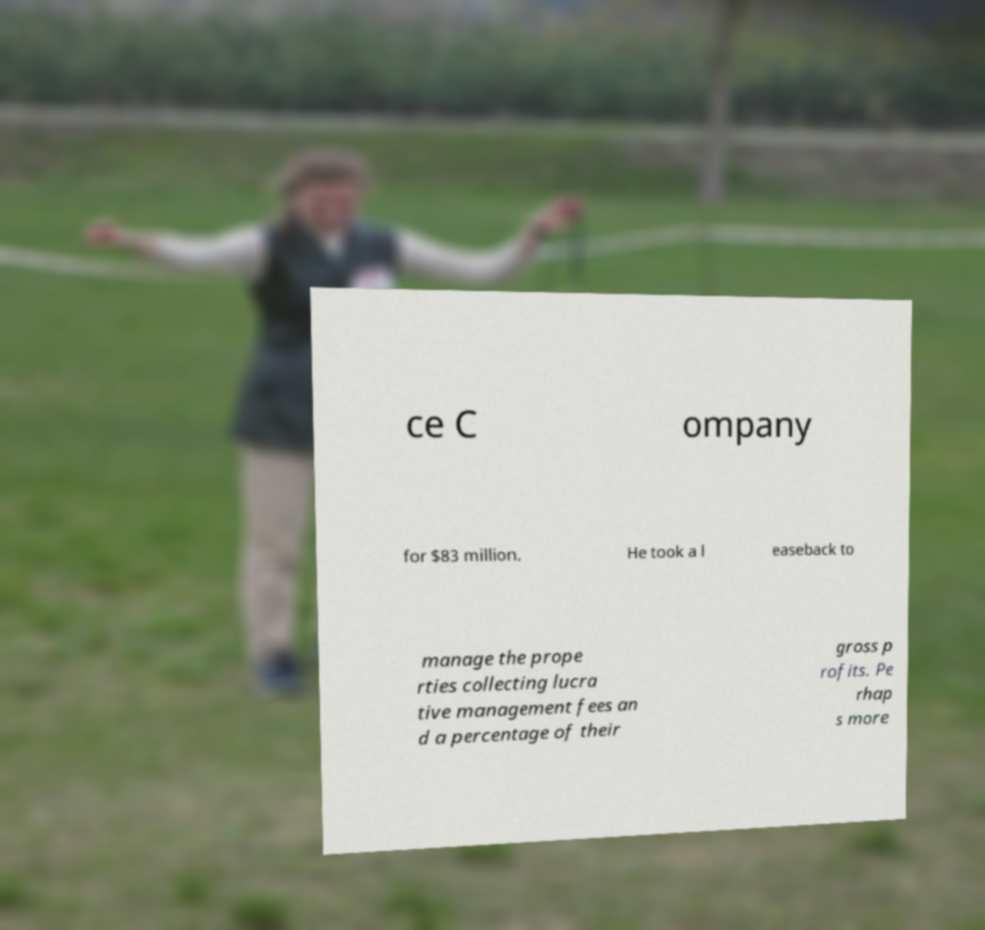Please read and relay the text visible in this image. What does it say? ce C ompany for $83 million. He took a l easeback to manage the prope rties collecting lucra tive management fees an d a percentage of their gross p rofits. Pe rhap s more 